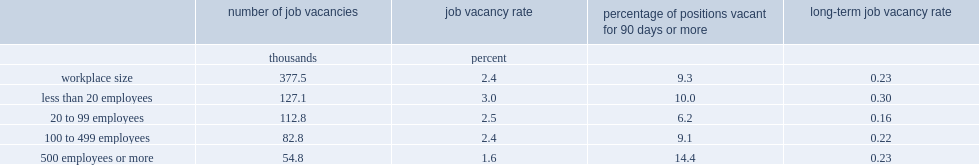Give me the full table as a dictionary. {'header': ['', 'number of job vacancies', 'job vacancy rate', 'percentage of positions vacant for 90 days or more', 'long-term job vacancy rate'], 'rows': [['', 'thousands', 'percent', '', ''], ['workplace size', '377.5', '2.4', '9.3', '0.23'], ['less than 20 employees', '127.1', '3.0', '10.0', '0.30'], ['20 to 99 employees', '112.8', '2.5', '6.2', '0.16'], ['100 to 499 employees', '82.8', '2.4', '9.1', '0.22'], ['500 employees or more', '54.8', '1.6', '14.4', '0.23']]} In 2016, which workplace size has the highest prevalence of positions vacant for 90 days or more? 500 employees or more. What proportion of positions vacant for 90 days or more is in workplaces with 20 to 99 employees? 6.2. What proportion of positions vacant for 90 days or more is in workplaces with 100 to 499 employees. 9.1. What proportion of positions vacant for 90 days or more is in workplaces with less than 20 employees? 10.0. Which workplace size has the highest long-term vacancy rate? Less than 20 employees. 